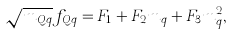<formula> <loc_0><loc_0><loc_500><loc_500>\sqrt { m _ { Q q } } f _ { Q q } = F _ { 1 } + F _ { 2 } m _ { q } + F _ { 3 } m _ { q } ^ { 2 } ,</formula> 